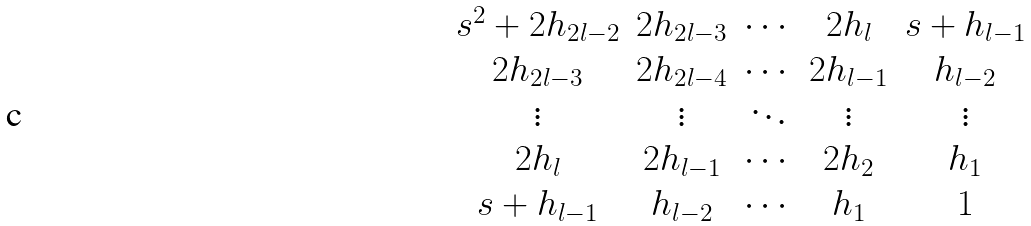Convert formula to latex. <formula><loc_0><loc_0><loc_500><loc_500>\begin{matrix} s ^ { 2 } + 2 h _ { 2 l - 2 } & 2 h _ { 2 l - 3 } & \cdots & 2 h _ { l } & s + h _ { l - 1 } \\ 2 h _ { 2 l - 3 } & 2 h _ { 2 l - 4 } & \cdots & 2 h _ { l - 1 } & h _ { l - 2 } \\ \vdots & \vdots & \ddots & \vdots & \vdots \\ 2 h _ { l } & 2 h _ { l - 1 } & \cdots & 2 h _ { 2 } & h _ { 1 } \\ s + h _ { l - 1 } & h _ { l - 2 } & \cdots & h _ { 1 } & 1 \end{matrix}</formula> 